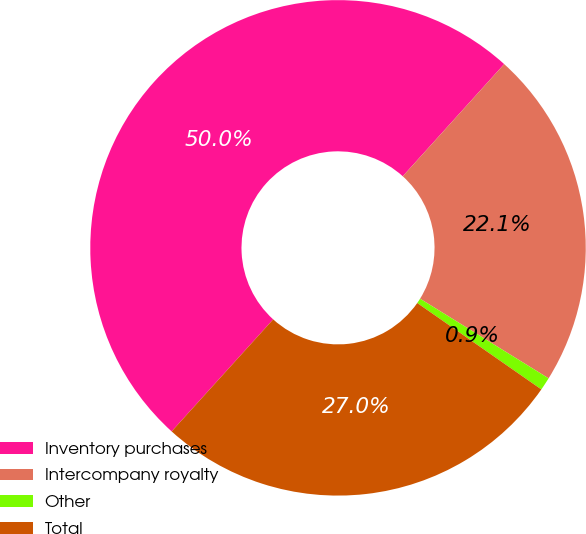Convert chart. <chart><loc_0><loc_0><loc_500><loc_500><pie_chart><fcel>Inventory purchases<fcel>Intercompany royalty<fcel>Other<fcel>Total<nl><fcel>49.98%<fcel>22.13%<fcel>0.85%<fcel>27.04%<nl></chart> 